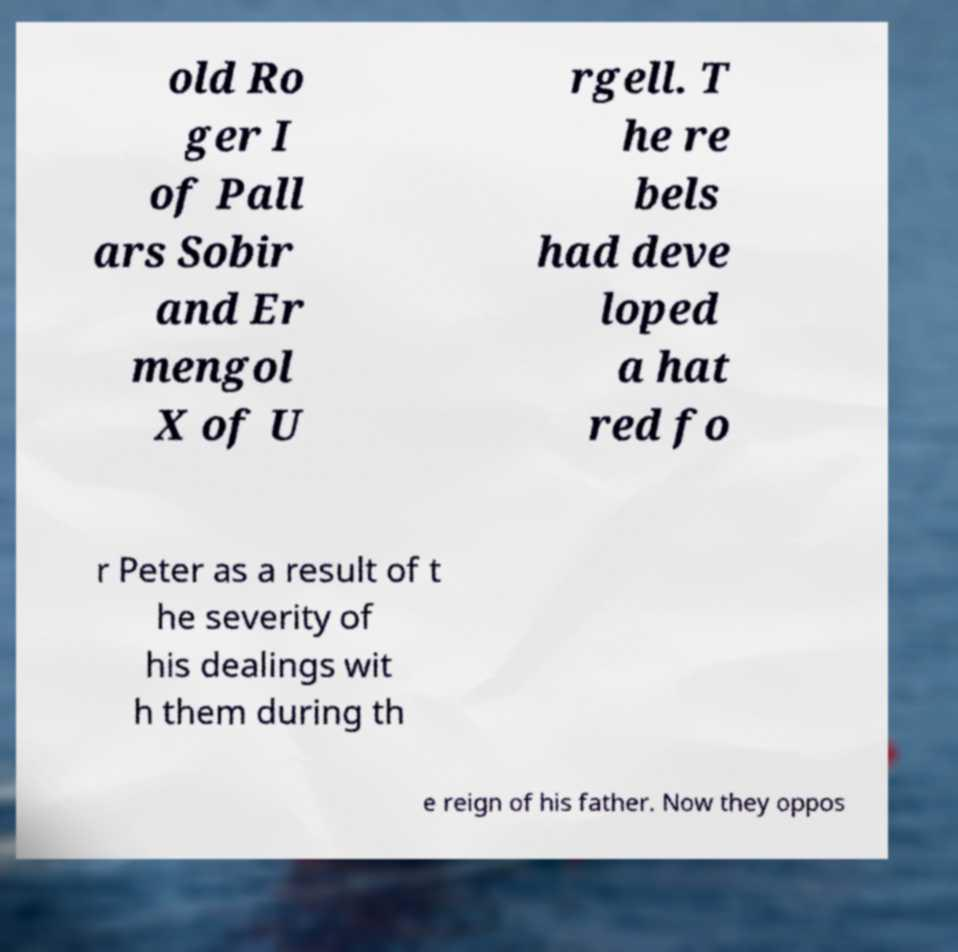Could you extract and type out the text from this image? old Ro ger I of Pall ars Sobir and Er mengol X of U rgell. T he re bels had deve loped a hat red fo r Peter as a result of t he severity of his dealings wit h them during th e reign of his father. Now they oppos 